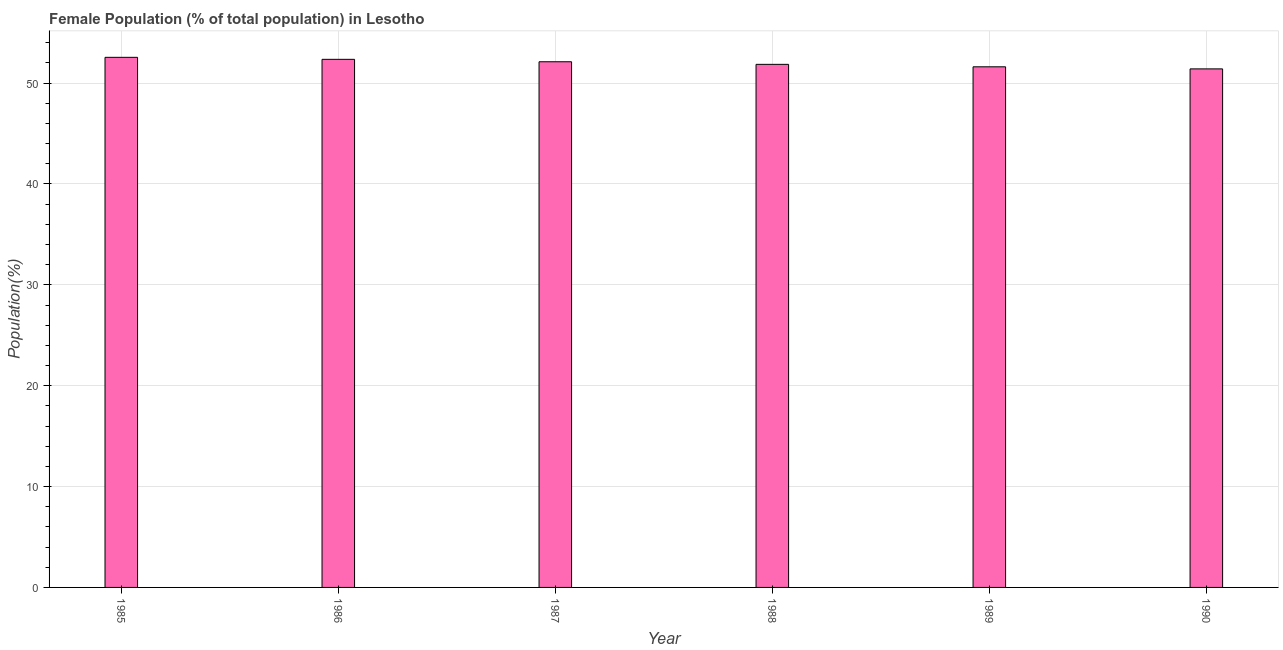Does the graph contain any zero values?
Make the answer very short. No. Does the graph contain grids?
Your answer should be compact. Yes. What is the title of the graph?
Your answer should be very brief. Female Population (% of total population) in Lesotho. What is the label or title of the Y-axis?
Give a very brief answer. Population(%). What is the female population in 1986?
Your response must be concise. 52.36. Across all years, what is the maximum female population?
Keep it short and to the point. 52.56. Across all years, what is the minimum female population?
Ensure brevity in your answer.  51.41. In which year was the female population maximum?
Provide a short and direct response. 1985. In which year was the female population minimum?
Make the answer very short. 1990. What is the sum of the female population?
Your answer should be compact. 311.92. What is the difference between the female population in 1986 and 1990?
Provide a succinct answer. 0.95. What is the average female population per year?
Keep it short and to the point. 51.99. What is the median female population?
Your answer should be compact. 51.99. In how many years, is the female population greater than 10 %?
Offer a very short reply. 6. Do a majority of the years between 1986 and 1990 (inclusive) have female population greater than 22 %?
Provide a succinct answer. Yes. What is the ratio of the female population in 1987 to that in 1989?
Ensure brevity in your answer.  1.01. What is the difference between the highest and the second highest female population?
Offer a very short reply. 0.2. Is the sum of the female population in 1985 and 1990 greater than the maximum female population across all years?
Make the answer very short. Yes. What is the difference between the highest and the lowest female population?
Make the answer very short. 1.15. In how many years, is the female population greater than the average female population taken over all years?
Keep it short and to the point. 3. How many bars are there?
Make the answer very short. 6. How many years are there in the graph?
Your response must be concise. 6. What is the difference between two consecutive major ticks on the Y-axis?
Your answer should be compact. 10. Are the values on the major ticks of Y-axis written in scientific E-notation?
Your answer should be very brief. No. What is the Population(%) of 1985?
Keep it short and to the point. 52.56. What is the Population(%) of 1986?
Make the answer very short. 52.36. What is the Population(%) in 1987?
Provide a short and direct response. 52.12. What is the Population(%) in 1988?
Your answer should be compact. 51.86. What is the Population(%) in 1989?
Offer a terse response. 51.62. What is the Population(%) of 1990?
Ensure brevity in your answer.  51.41. What is the difference between the Population(%) in 1985 and 1986?
Ensure brevity in your answer.  0.2. What is the difference between the Population(%) in 1985 and 1987?
Give a very brief answer. 0.44. What is the difference between the Population(%) in 1985 and 1988?
Your response must be concise. 0.7. What is the difference between the Population(%) in 1985 and 1989?
Offer a terse response. 0.94. What is the difference between the Population(%) in 1985 and 1990?
Your answer should be compact. 1.15. What is the difference between the Population(%) in 1986 and 1987?
Offer a very short reply. 0.24. What is the difference between the Population(%) in 1986 and 1988?
Your answer should be compact. 0.5. What is the difference between the Population(%) in 1986 and 1989?
Offer a terse response. 0.74. What is the difference between the Population(%) in 1986 and 1990?
Your answer should be compact. 0.95. What is the difference between the Population(%) in 1987 and 1988?
Make the answer very short. 0.26. What is the difference between the Population(%) in 1987 and 1989?
Provide a short and direct response. 0.5. What is the difference between the Population(%) in 1987 and 1990?
Your answer should be very brief. 0.71. What is the difference between the Population(%) in 1988 and 1989?
Provide a succinct answer. 0.24. What is the difference between the Population(%) in 1988 and 1990?
Offer a terse response. 0.45. What is the difference between the Population(%) in 1989 and 1990?
Give a very brief answer. 0.21. What is the ratio of the Population(%) in 1985 to that in 1986?
Your response must be concise. 1. What is the ratio of the Population(%) in 1985 to that in 1987?
Ensure brevity in your answer.  1.01. What is the ratio of the Population(%) in 1985 to that in 1988?
Keep it short and to the point. 1.01. What is the ratio of the Population(%) in 1985 to that in 1989?
Ensure brevity in your answer.  1.02. What is the ratio of the Population(%) in 1986 to that in 1988?
Your response must be concise. 1.01. What is the ratio of the Population(%) in 1986 to that in 1989?
Offer a terse response. 1.01. What is the ratio of the Population(%) in 1986 to that in 1990?
Your answer should be compact. 1.02. What is the ratio of the Population(%) in 1987 to that in 1989?
Keep it short and to the point. 1.01. What is the ratio of the Population(%) in 1987 to that in 1990?
Provide a short and direct response. 1.01. 